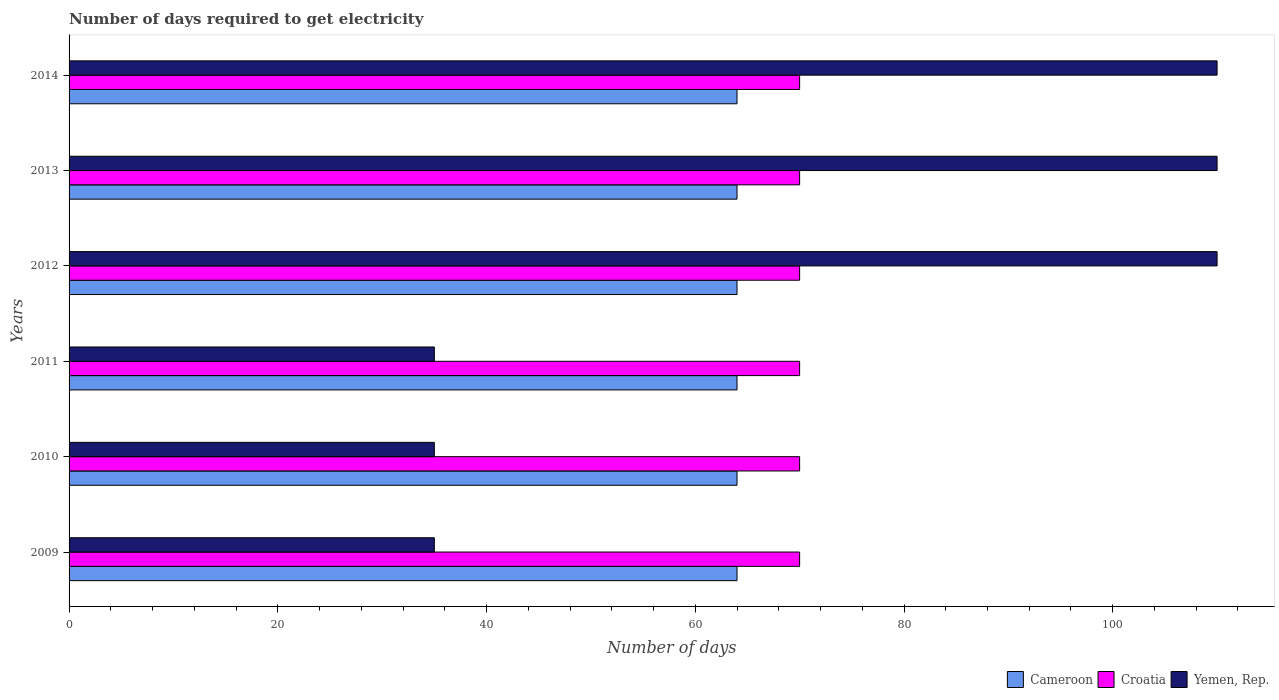Are the number of bars per tick equal to the number of legend labels?
Provide a succinct answer. Yes. Are the number of bars on each tick of the Y-axis equal?
Provide a succinct answer. Yes. How many bars are there on the 5th tick from the top?
Give a very brief answer. 3. How many bars are there on the 4th tick from the bottom?
Provide a succinct answer. 3. What is the number of days required to get electricity in in Yemen, Rep. in 2013?
Provide a succinct answer. 110. Across all years, what is the maximum number of days required to get electricity in in Cameroon?
Your answer should be compact. 64. Across all years, what is the minimum number of days required to get electricity in in Cameroon?
Offer a very short reply. 64. In which year was the number of days required to get electricity in in Croatia maximum?
Provide a short and direct response. 2009. In which year was the number of days required to get electricity in in Yemen, Rep. minimum?
Your answer should be compact. 2009. What is the total number of days required to get electricity in in Croatia in the graph?
Offer a very short reply. 420. What is the difference between the number of days required to get electricity in in Cameroon in 2010 and the number of days required to get electricity in in Yemen, Rep. in 2011?
Provide a succinct answer. 29. What is the average number of days required to get electricity in in Croatia per year?
Your response must be concise. 70. In the year 2010, what is the difference between the number of days required to get electricity in in Cameroon and number of days required to get electricity in in Croatia?
Offer a very short reply. -6. In how many years, is the number of days required to get electricity in in Cameroon greater than 28 days?
Provide a short and direct response. 6. Is the number of days required to get electricity in in Cameroon in 2010 less than that in 2013?
Your response must be concise. No. What is the difference between the highest and the lowest number of days required to get electricity in in Yemen, Rep.?
Give a very brief answer. 75. What does the 1st bar from the top in 2014 represents?
Offer a terse response. Yemen, Rep. What does the 2nd bar from the bottom in 2013 represents?
Your response must be concise. Croatia. Is it the case that in every year, the sum of the number of days required to get electricity in in Cameroon and number of days required to get electricity in in Yemen, Rep. is greater than the number of days required to get electricity in in Croatia?
Make the answer very short. Yes. Are the values on the major ticks of X-axis written in scientific E-notation?
Offer a very short reply. No. Does the graph contain grids?
Offer a very short reply. No. How many legend labels are there?
Ensure brevity in your answer.  3. What is the title of the graph?
Ensure brevity in your answer.  Number of days required to get electricity. What is the label or title of the X-axis?
Your answer should be compact. Number of days. What is the Number of days of Cameroon in 2009?
Provide a short and direct response. 64. What is the Number of days of Yemen, Rep. in 2009?
Provide a short and direct response. 35. What is the Number of days of Cameroon in 2010?
Make the answer very short. 64. What is the Number of days of Cameroon in 2011?
Give a very brief answer. 64. What is the Number of days in Yemen, Rep. in 2011?
Your answer should be compact. 35. What is the Number of days of Cameroon in 2012?
Offer a terse response. 64. What is the Number of days in Croatia in 2012?
Ensure brevity in your answer.  70. What is the Number of days of Yemen, Rep. in 2012?
Give a very brief answer. 110. What is the Number of days in Yemen, Rep. in 2013?
Give a very brief answer. 110. What is the Number of days in Cameroon in 2014?
Your response must be concise. 64. What is the Number of days of Yemen, Rep. in 2014?
Provide a short and direct response. 110. Across all years, what is the maximum Number of days of Yemen, Rep.?
Offer a very short reply. 110. Across all years, what is the minimum Number of days in Yemen, Rep.?
Your answer should be very brief. 35. What is the total Number of days of Cameroon in the graph?
Your answer should be very brief. 384. What is the total Number of days in Croatia in the graph?
Ensure brevity in your answer.  420. What is the total Number of days of Yemen, Rep. in the graph?
Your response must be concise. 435. What is the difference between the Number of days of Yemen, Rep. in 2009 and that in 2011?
Give a very brief answer. 0. What is the difference between the Number of days of Croatia in 2009 and that in 2012?
Ensure brevity in your answer.  0. What is the difference between the Number of days of Yemen, Rep. in 2009 and that in 2012?
Your answer should be very brief. -75. What is the difference between the Number of days of Cameroon in 2009 and that in 2013?
Your answer should be very brief. 0. What is the difference between the Number of days of Yemen, Rep. in 2009 and that in 2013?
Make the answer very short. -75. What is the difference between the Number of days in Cameroon in 2009 and that in 2014?
Provide a succinct answer. 0. What is the difference between the Number of days in Yemen, Rep. in 2009 and that in 2014?
Offer a terse response. -75. What is the difference between the Number of days of Yemen, Rep. in 2010 and that in 2012?
Keep it short and to the point. -75. What is the difference between the Number of days of Cameroon in 2010 and that in 2013?
Offer a very short reply. 0. What is the difference between the Number of days of Croatia in 2010 and that in 2013?
Your response must be concise. 0. What is the difference between the Number of days of Yemen, Rep. in 2010 and that in 2013?
Provide a short and direct response. -75. What is the difference between the Number of days in Yemen, Rep. in 2010 and that in 2014?
Make the answer very short. -75. What is the difference between the Number of days in Croatia in 2011 and that in 2012?
Your response must be concise. 0. What is the difference between the Number of days in Yemen, Rep. in 2011 and that in 2012?
Give a very brief answer. -75. What is the difference between the Number of days of Cameroon in 2011 and that in 2013?
Make the answer very short. 0. What is the difference between the Number of days in Croatia in 2011 and that in 2013?
Ensure brevity in your answer.  0. What is the difference between the Number of days of Yemen, Rep. in 2011 and that in 2013?
Your answer should be compact. -75. What is the difference between the Number of days in Yemen, Rep. in 2011 and that in 2014?
Provide a succinct answer. -75. What is the difference between the Number of days of Yemen, Rep. in 2012 and that in 2013?
Give a very brief answer. 0. What is the difference between the Number of days of Cameroon in 2012 and that in 2014?
Provide a short and direct response. 0. What is the difference between the Number of days in Croatia in 2013 and that in 2014?
Your response must be concise. 0. What is the difference between the Number of days in Cameroon in 2009 and the Number of days in Croatia in 2010?
Your answer should be compact. -6. What is the difference between the Number of days in Cameroon in 2009 and the Number of days in Yemen, Rep. in 2010?
Ensure brevity in your answer.  29. What is the difference between the Number of days of Cameroon in 2009 and the Number of days of Yemen, Rep. in 2011?
Provide a short and direct response. 29. What is the difference between the Number of days in Cameroon in 2009 and the Number of days in Yemen, Rep. in 2012?
Keep it short and to the point. -46. What is the difference between the Number of days in Croatia in 2009 and the Number of days in Yemen, Rep. in 2012?
Your answer should be compact. -40. What is the difference between the Number of days in Cameroon in 2009 and the Number of days in Croatia in 2013?
Offer a terse response. -6. What is the difference between the Number of days in Cameroon in 2009 and the Number of days in Yemen, Rep. in 2013?
Keep it short and to the point. -46. What is the difference between the Number of days in Cameroon in 2009 and the Number of days in Yemen, Rep. in 2014?
Provide a short and direct response. -46. What is the difference between the Number of days in Cameroon in 2010 and the Number of days in Yemen, Rep. in 2012?
Provide a succinct answer. -46. What is the difference between the Number of days of Cameroon in 2010 and the Number of days of Croatia in 2013?
Offer a terse response. -6. What is the difference between the Number of days in Cameroon in 2010 and the Number of days in Yemen, Rep. in 2013?
Keep it short and to the point. -46. What is the difference between the Number of days in Cameroon in 2010 and the Number of days in Yemen, Rep. in 2014?
Offer a terse response. -46. What is the difference between the Number of days in Croatia in 2010 and the Number of days in Yemen, Rep. in 2014?
Offer a terse response. -40. What is the difference between the Number of days of Cameroon in 2011 and the Number of days of Croatia in 2012?
Your response must be concise. -6. What is the difference between the Number of days of Cameroon in 2011 and the Number of days of Yemen, Rep. in 2012?
Make the answer very short. -46. What is the difference between the Number of days of Croatia in 2011 and the Number of days of Yemen, Rep. in 2012?
Make the answer very short. -40. What is the difference between the Number of days in Cameroon in 2011 and the Number of days in Yemen, Rep. in 2013?
Make the answer very short. -46. What is the difference between the Number of days of Cameroon in 2011 and the Number of days of Croatia in 2014?
Give a very brief answer. -6. What is the difference between the Number of days in Cameroon in 2011 and the Number of days in Yemen, Rep. in 2014?
Give a very brief answer. -46. What is the difference between the Number of days in Croatia in 2011 and the Number of days in Yemen, Rep. in 2014?
Provide a short and direct response. -40. What is the difference between the Number of days of Cameroon in 2012 and the Number of days of Yemen, Rep. in 2013?
Make the answer very short. -46. What is the difference between the Number of days of Croatia in 2012 and the Number of days of Yemen, Rep. in 2013?
Your response must be concise. -40. What is the difference between the Number of days in Cameroon in 2012 and the Number of days in Yemen, Rep. in 2014?
Your response must be concise. -46. What is the difference between the Number of days of Cameroon in 2013 and the Number of days of Yemen, Rep. in 2014?
Offer a very short reply. -46. What is the difference between the Number of days of Croatia in 2013 and the Number of days of Yemen, Rep. in 2014?
Provide a short and direct response. -40. What is the average Number of days of Croatia per year?
Keep it short and to the point. 70. What is the average Number of days in Yemen, Rep. per year?
Offer a very short reply. 72.5. In the year 2009, what is the difference between the Number of days of Croatia and Number of days of Yemen, Rep.?
Your answer should be compact. 35. In the year 2010, what is the difference between the Number of days of Cameroon and Number of days of Yemen, Rep.?
Offer a very short reply. 29. In the year 2010, what is the difference between the Number of days in Croatia and Number of days in Yemen, Rep.?
Offer a very short reply. 35. In the year 2011, what is the difference between the Number of days in Cameroon and Number of days in Croatia?
Your response must be concise. -6. In the year 2011, what is the difference between the Number of days of Cameroon and Number of days of Yemen, Rep.?
Provide a succinct answer. 29. In the year 2012, what is the difference between the Number of days in Cameroon and Number of days in Croatia?
Provide a short and direct response. -6. In the year 2012, what is the difference between the Number of days of Cameroon and Number of days of Yemen, Rep.?
Provide a succinct answer. -46. In the year 2013, what is the difference between the Number of days of Cameroon and Number of days of Yemen, Rep.?
Offer a terse response. -46. In the year 2013, what is the difference between the Number of days in Croatia and Number of days in Yemen, Rep.?
Offer a terse response. -40. In the year 2014, what is the difference between the Number of days of Cameroon and Number of days of Croatia?
Offer a very short reply. -6. In the year 2014, what is the difference between the Number of days in Cameroon and Number of days in Yemen, Rep.?
Ensure brevity in your answer.  -46. In the year 2014, what is the difference between the Number of days in Croatia and Number of days in Yemen, Rep.?
Ensure brevity in your answer.  -40. What is the ratio of the Number of days of Cameroon in 2009 to that in 2011?
Ensure brevity in your answer.  1. What is the ratio of the Number of days in Croatia in 2009 to that in 2011?
Your response must be concise. 1. What is the ratio of the Number of days in Yemen, Rep. in 2009 to that in 2011?
Make the answer very short. 1. What is the ratio of the Number of days of Cameroon in 2009 to that in 2012?
Keep it short and to the point. 1. What is the ratio of the Number of days of Croatia in 2009 to that in 2012?
Give a very brief answer. 1. What is the ratio of the Number of days in Yemen, Rep. in 2009 to that in 2012?
Offer a terse response. 0.32. What is the ratio of the Number of days in Croatia in 2009 to that in 2013?
Provide a short and direct response. 1. What is the ratio of the Number of days of Yemen, Rep. in 2009 to that in 2013?
Keep it short and to the point. 0.32. What is the ratio of the Number of days of Yemen, Rep. in 2009 to that in 2014?
Your response must be concise. 0.32. What is the ratio of the Number of days of Cameroon in 2010 to that in 2011?
Your answer should be compact. 1. What is the ratio of the Number of days in Yemen, Rep. in 2010 to that in 2011?
Ensure brevity in your answer.  1. What is the ratio of the Number of days in Cameroon in 2010 to that in 2012?
Your answer should be very brief. 1. What is the ratio of the Number of days of Yemen, Rep. in 2010 to that in 2012?
Give a very brief answer. 0.32. What is the ratio of the Number of days of Cameroon in 2010 to that in 2013?
Your answer should be very brief. 1. What is the ratio of the Number of days of Yemen, Rep. in 2010 to that in 2013?
Provide a succinct answer. 0.32. What is the ratio of the Number of days of Cameroon in 2010 to that in 2014?
Keep it short and to the point. 1. What is the ratio of the Number of days of Yemen, Rep. in 2010 to that in 2014?
Provide a short and direct response. 0.32. What is the ratio of the Number of days of Yemen, Rep. in 2011 to that in 2012?
Make the answer very short. 0.32. What is the ratio of the Number of days in Cameroon in 2011 to that in 2013?
Your response must be concise. 1. What is the ratio of the Number of days in Croatia in 2011 to that in 2013?
Your response must be concise. 1. What is the ratio of the Number of days of Yemen, Rep. in 2011 to that in 2013?
Give a very brief answer. 0.32. What is the ratio of the Number of days of Croatia in 2011 to that in 2014?
Provide a succinct answer. 1. What is the ratio of the Number of days of Yemen, Rep. in 2011 to that in 2014?
Your answer should be compact. 0.32. What is the ratio of the Number of days of Croatia in 2012 to that in 2013?
Give a very brief answer. 1. What is the ratio of the Number of days in Yemen, Rep. in 2012 to that in 2013?
Provide a succinct answer. 1. What is the ratio of the Number of days in Cameroon in 2012 to that in 2014?
Provide a succinct answer. 1. What is the ratio of the Number of days in Croatia in 2013 to that in 2014?
Offer a very short reply. 1. What is the ratio of the Number of days in Yemen, Rep. in 2013 to that in 2014?
Your answer should be very brief. 1. What is the difference between the highest and the second highest Number of days in Cameroon?
Keep it short and to the point. 0. What is the difference between the highest and the lowest Number of days in Yemen, Rep.?
Provide a succinct answer. 75. 